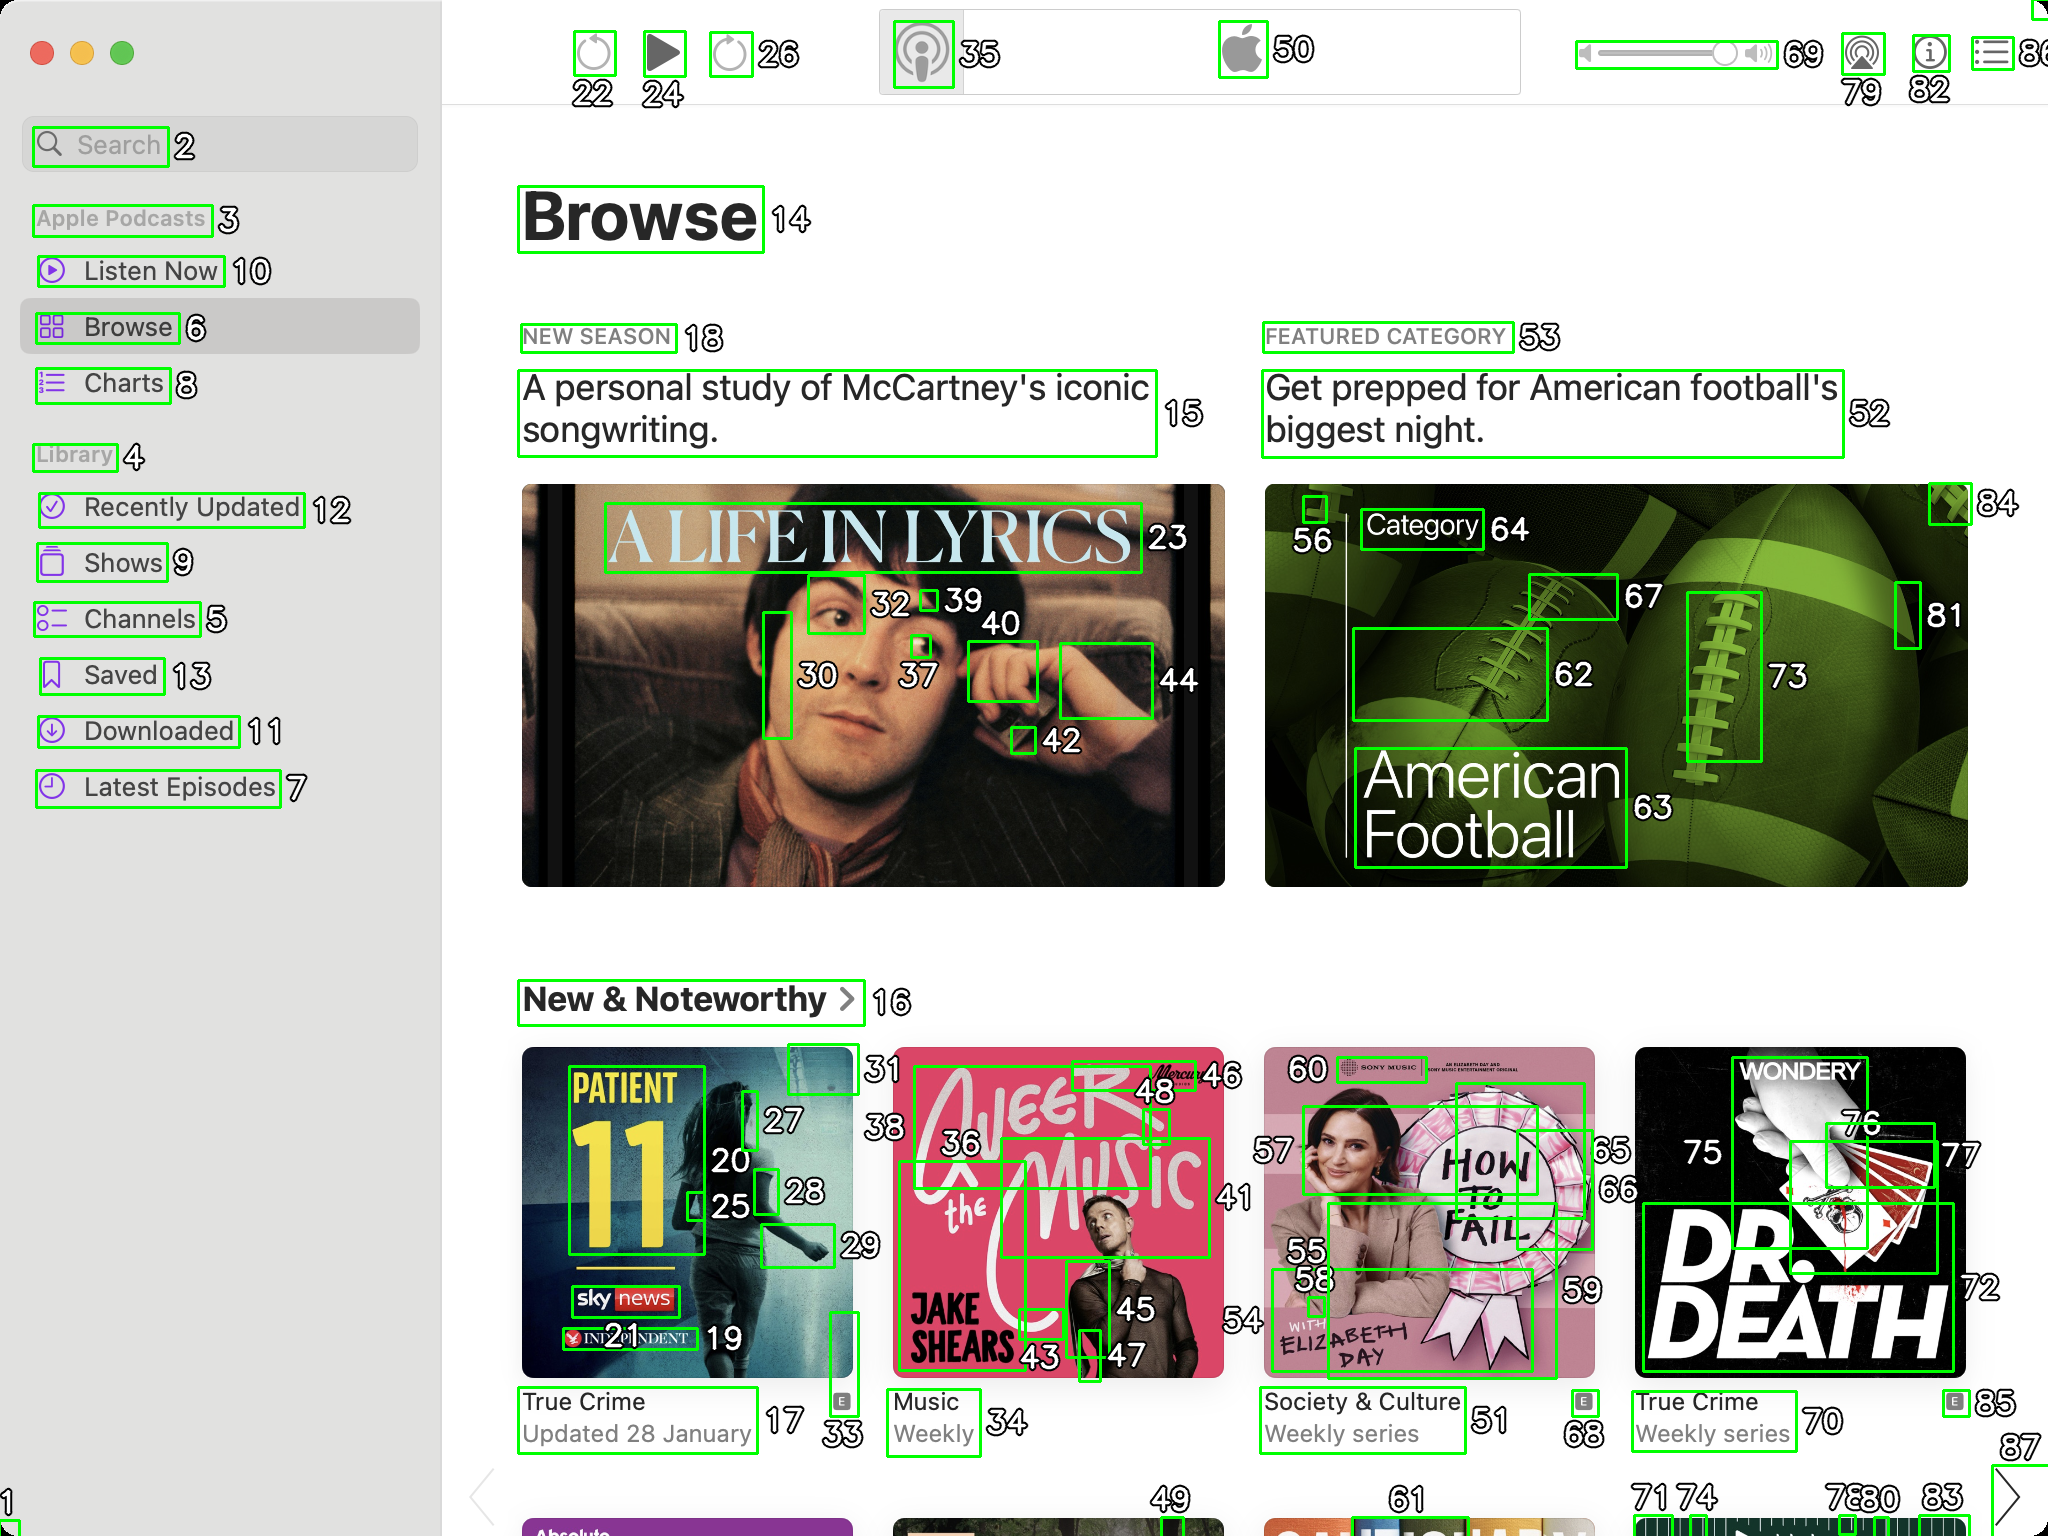You are an AI designed for image processing and segmentation analysis, particularly skilled in merging segmented regions of an image to improve accuracy and readability.

**Task Description:**
Your task is to address a user's concern with a UI screenshot of the Apple Podcasts application on MacOS. The screenshot contains multiple green boxes, each representing a UI element, with a unique white number outlined in black ranging from 1 to 88. Due to segmentation issues, some boxes that belong to the same image are divided unnaturally.

**Objective:**
Merge these segmented areas that correspond to a single UI element to create a coherent representation. The final output should be in JSON format, where each key-value pair represents the merged areas.

**Example JSON Output:**
If boxes with numbers 1, 2, and 3 should belong to the same UI element, the JSON output should be:

```json
{
    "Image A Life In Lyrics": [1, 2, 3]
}
```

If box has only one box, omit that box.

**Instructions:**

- **Identify Segmented Regions:** Analyze the screenshot to identify which green boxes belong to the same UI element.
- **Merge Regions:** Group the numbers of these boxes together to represent a single UI element.
- **Output Format:** Produce the output in JSON format, with each key representing a UI element and each value being a list of the numbers of the merged boxes.

**Primary Objective:**
Ensure the accuracy of the merged regions based on the user's supplied image information, maintaining the integrity and structure of the UI elements in the Apple Podcasts application on MacOS. ```json
{
    "Search": [2],
    "Apple Podcasts": [3],
    "Listen Now": [10],
    "Browse": [6, 14],
    "Charts": [8],
    "Library": [4],
    "Recently Updated": [12],
    "Shows": [9],
    "Channels": [5],
    "Saved": [13],
    "Downloaded": [11],
    "Latest Episodes": [7],
    "Play Button": [22],
    "Forward Button": [24],
    "Volume Button": [26],
    "Settings Button": [35],
    "Apple Logo": [50],
    "Volume Slider": [69, 79, 82],
    "A Life In Lyrics": [23, 30, 32, 37, 39, 40, 42, 44],
    "New Season": [18],
    "A personal study of McCartney's iconic songwriting.": [15],
    "Featured Category": [53],
    "Get prepped for American football's biggest night.": [52],
    "American Football": [56, 62, 63, 64, 67, 73, 81, 84],
    "New & Noteworthy": [16],
    "Patient 11": [17, 20, 25, 27, 28, 33],
    "True Crime Updated 28 January": [31],
    "A Beer With Jake": [36, 43, 45, 46, 48],
    "Music Weekly": [47],
    "How To Fail": [55, 58, 59, 60],
    "Society & Culture Weekly series": [51],
    "Dr. Death": [70, 72, 75, 76, 77],
    "True Crime Weekly series": [68, 85],
    "Podcast 1": [71, 74, 78, 80, 83]
}
``` 